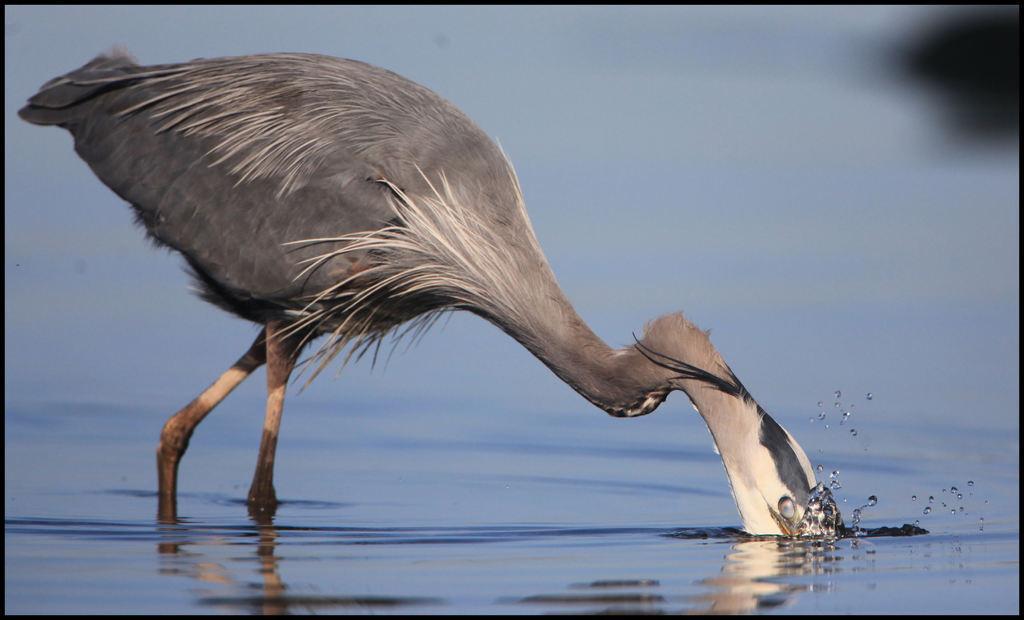In one or two sentences, can you explain what this image depicts? This is an edited image. I can see a bird standing and drinking water. The background looks blurry. 